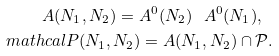Convert formula to latex. <formula><loc_0><loc_0><loc_500><loc_500>A ( N _ { 1 } , N _ { 2 } ) = A ^ { 0 } ( N _ { 2 } ) \ A ^ { 0 } ( N _ { 1 } ) , \ \\ m a t h c a l { P } ( N _ { 1 } , N _ { 2 } ) = A ( N _ { 1 } , N _ { 2 } ) \cap \mathcal { P } .</formula> 